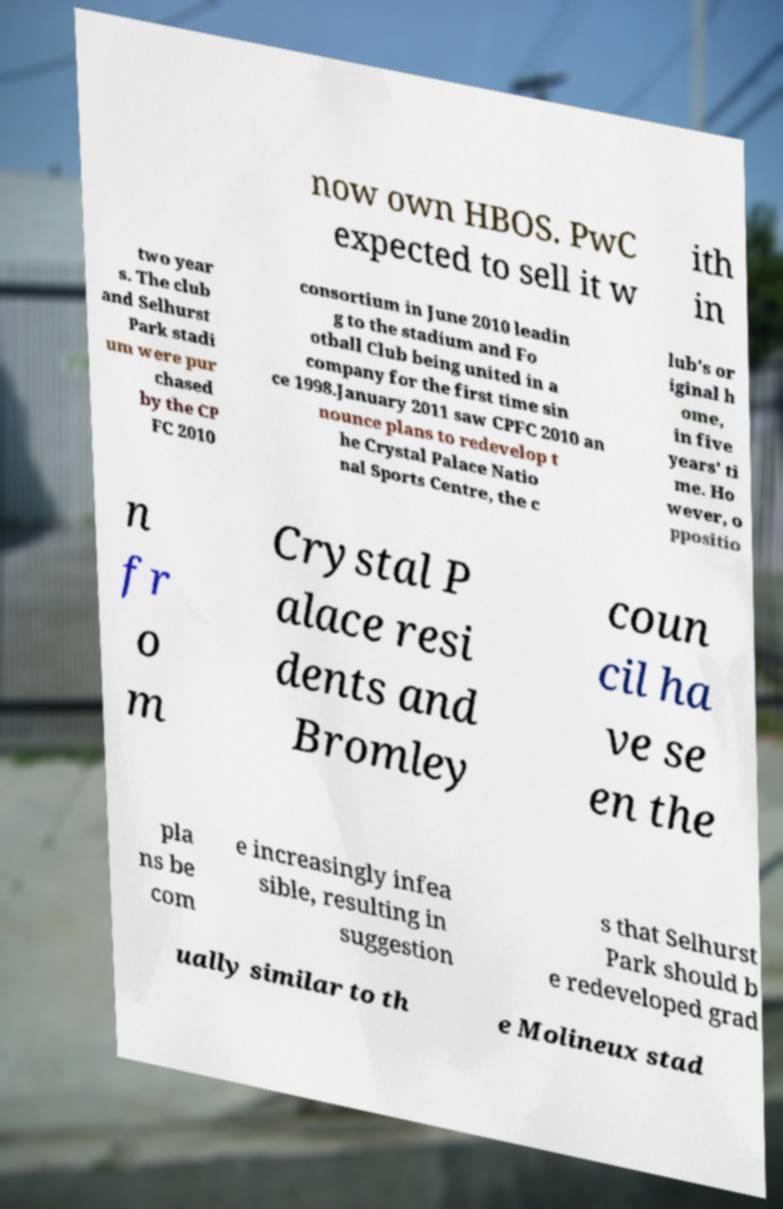What messages or text are displayed in this image? I need them in a readable, typed format. now own HBOS. PwC expected to sell it w ith in two year s. The club and Selhurst Park stadi um were pur chased by the CP FC 2010 consortium in June 2010 leadin g to the stadium and Fo otball Club being united in a company for the first time sin ce 1998.January 2011 saw CPFC 2010 an nounce plans to redevelop t he Crystal Palace Natio nal Sports Centre, the c lub's or iginal h ome, in five years' ti me. Ho wever, o ppositio n fr o m Crystal P alace resi dents and Bromley coun cil ha ve se en the pla ns be com e increasingly infea sible, resulting in suggestion s that Selhurst Park should b e redeveloped grad ually similar to th e Molineux stad 